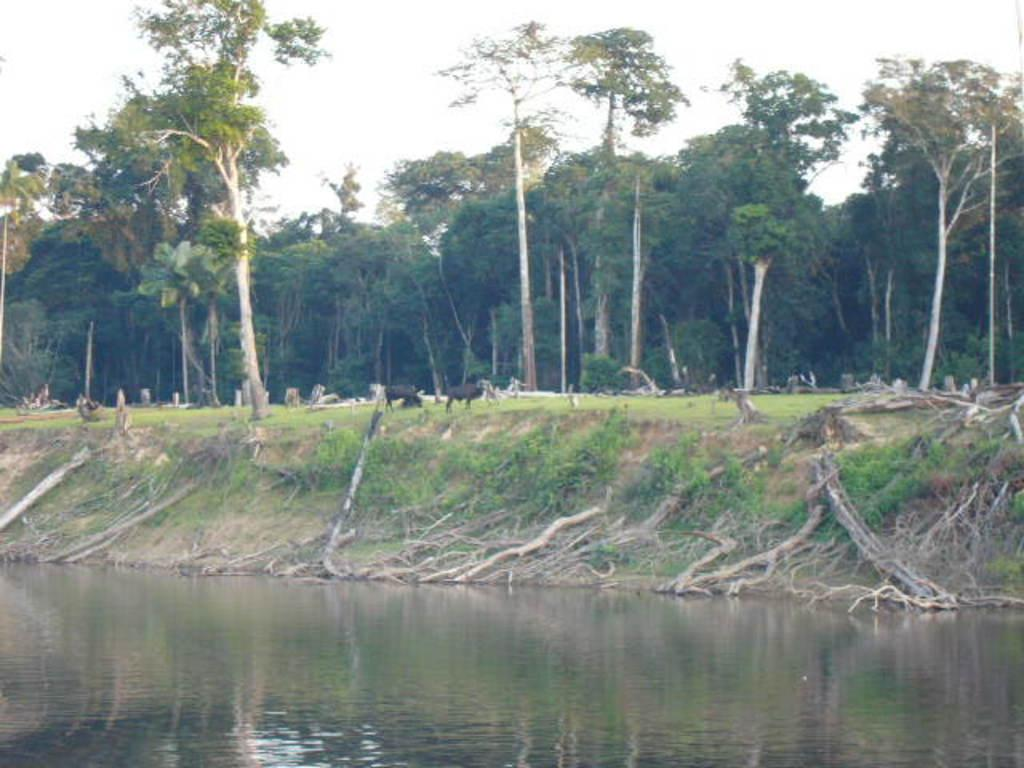What is visible in the image? Water is visible in the image. What can be seen in the background of the image? There are trees in the background of the image. What is the color of the trees? The trees are green in color. What is the color of the sky in the image? The sky is white in color. Where is the mine located in the image? There is no mine present in the image. What type of berry can be seen growing on the trees in the image? There are no berries visible on the trees in the image, and the trees are not described as having any fruit or berries. 